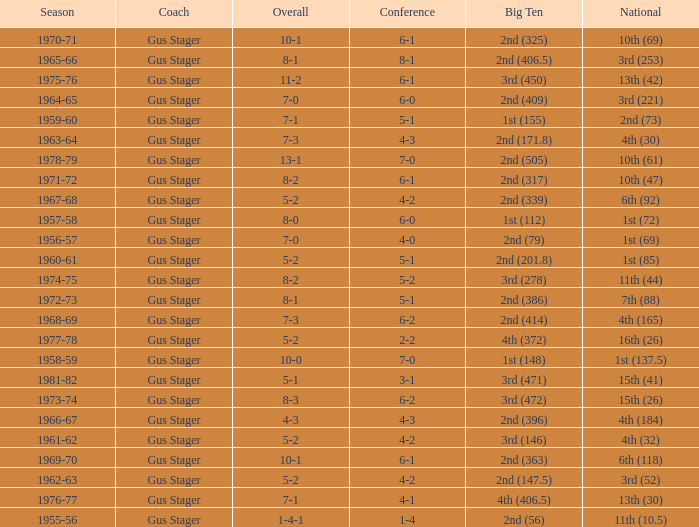What is the Season with a Big Ten that is 2nd (386)? 1972-73. 